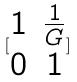Convert formula to latex. <formula><loc_0><loc_0><loc_500><loc_500>[ \begin{matrix} 1 & \frac { 1 } { G } \\ 0 & 1 \end{matrix} ]</formula> 